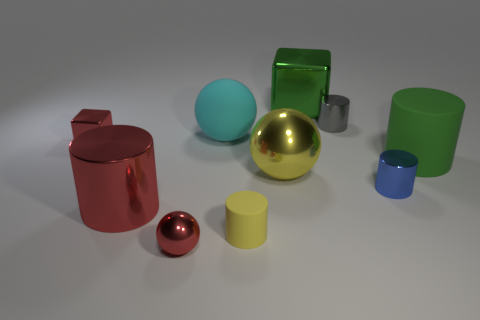Subtract all tiny blue cylinders. How many cylinders are left? 4 Subtract all blue cylinders. How many cylinders are left? 4 Subtract all green blocks. Subtract all gray cylinders. How many blocks are left? 1 Subtract all blue spheres. How many red cylinders are left? 1 Subtract all large purple cylinders. Subtract all tiny cubes. How many objects are left? 9 Add 2 big green things. How many big green things are left? 4 Add 5 small purple shiny balls. How many small purple shiny balls exist? 5 Subtract 0 brown balls. How many objects are left? 10 Subtract all blocks. How many objects are left? 8 Subtract 1 blocks. How many blocks are left? 1 